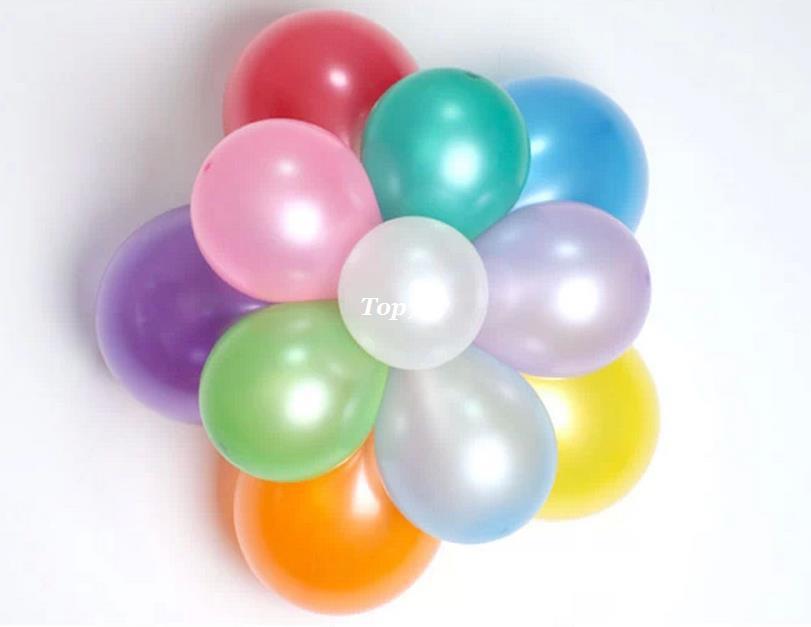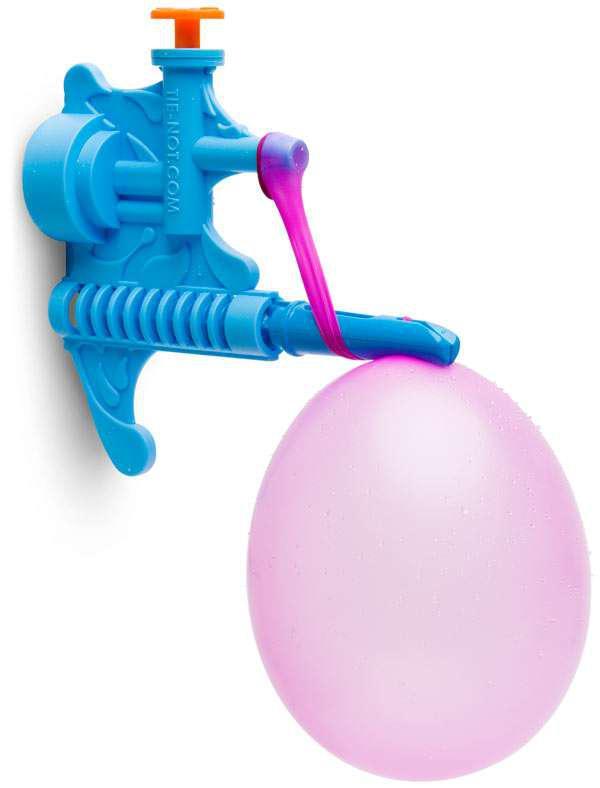The first image is the image on the left, the second image is the image on the right. For the images displayed, is the sentence "One of the image has exactly four balloons." factually correct? Answer yes or no. No. 